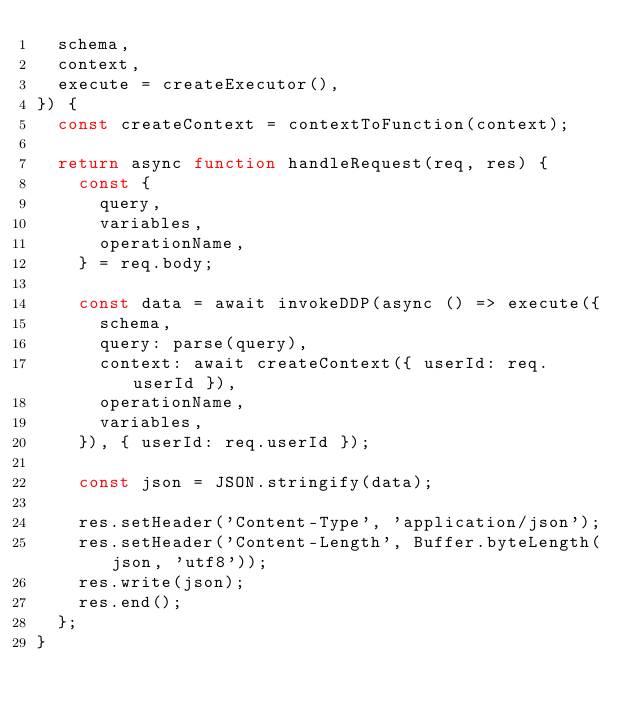<code> <loc_0><loc_0><loc_500><loc_500><_JavaScript_>  schema,
  context,
  execute = createExecutor(),
}) {
  const createContext = contextToFunction(context);

  return async function handleRequest(req, res) {
    const {
      query,
      variables,
      operationName,
    } = req.body;

    const data = await invokeDDP(async () => execute({
      schema,
      query: parse(query),
      context: await createContext({ userId: req.userId }),
      operationName,
      variables,
    }), { userId: req.userId });

    const json = JSON.stringify(data);

    res.setHeader('Content-Type', 'application/json');
    res.setHeader('Content-Length', Buffer.byteLength(json, 'utf8'));
    res.write(json);
    res.end();
  };
}
</code> 